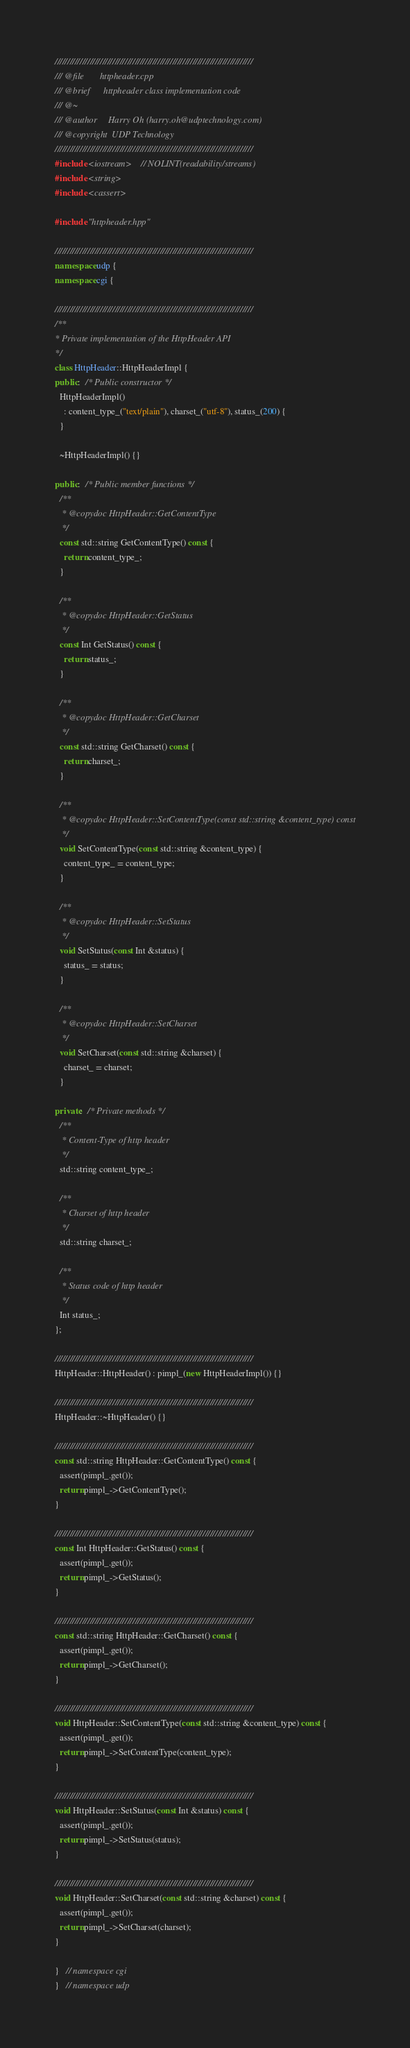Convert code to text. <code><loc_0><loc_0><loc_500><loc_500><_C++_>///////////////////////////////////////////////////////////////////////////////
/// @file       httpheader.cpp
/// @brief      httpheader class implementation code
/// @~
/// @author     Harry Oh (harry.oh@udptechnology.com)
/// @copyright  UDP Technology
///////////////////////////////////////////////////////////////////////////////
#include <iostream>    // NOLINT(readability/streams)
#include <string>
#include <cassert>

#include "httpheader.hpp"

///////////////////////////////////////////////////////////////////////////////
namespace udp {
namespace cgi {

///////////////////////////////////////////////////////////////////////////////
/**
* Private implementation of the HttpHeader API
*/
class HttpHeader::HttpHeaderImpl {
public:  /* Public constructor */
  HttpHeaderImpl()
    : content_type_("text/plain"), charset_("utf-8"), status_(200) {
  }

  ~HttpHeaderImpl() {}

public:  /* Public member functions */
  /**
   * @copydoc HttpHeader::GetContentType
   */
  const std::string GetContentType() const {
    return content_type_;
  }

  /**
   * @copydoc HttpHeader::GetStatus
   */
  const Int GetStatus() const {
    return status_;
  }

  /**
   * @copydoc HttpHeader::GetCharset
   */
  const std::string GetCharset() const {
    return charset_;
  }

  /**
   * @copydoc HttpHeader::SetContentType(const std::string &content_type) const
   */
  void SetContentType(const std::string &content_type) {
    content_type_ = content_type;
  }

  /**
   * @copydoc HttpHeader::SetStatus
   */
  void SetStatus(const Int &status) {
    status_ = status;
  }

  /**
   * @copydoc HttpHeader::SetCharset
   */
  void SetCharset(const std::string &charset) {
    charset_ = charset;
  }

private:  /* Private methods */
  /**
   * Content-Type of http header
   */
  std::string content_type_;

  /**
   * Charset of http header
   */
  std::string charset_;

  /**
   * Status code of http header
   */
  Int status_;
};

///////////////////////////////////////////////////////////////////////////////
HttpHeader::HttpHeader() : pimpl_(new HttpHeaderImpl()) {}

///////////////////////////////////////////////////////////////////////////////
HttpHeader::~HttpHeader() {}

///////////////////////////////////////////////////////////////////////////////
const std::string HttpHeader::GetContentType() const {
  assert(pimpl_.get());
  return pimpl_->GetContentType();
}

///////////////////////////////////////////////////////////////////////////////
const Int HttpHeader::GetStatus() const {
  assert(pimpl_.get());
  return pimpl_->GetStatus();
}

///////////////////////////////////////////////////////////////////////////////
const std::string HttpHeader::GetCharset() const {
  assert(pimpl_.get());
  return pimpl_->GetCharset();
}

///////////////////////////////////////////////////////////////////////////////
void HttpHeader::SetContentType(const std::string &content_type) const {
  assert(pimpl_.get());
  return pimpl_->SetContentType(content_type);
}

///////////////////////////////////////////////////////////////////////////////
void HttpHeader::SetStatus(const Int &status) const {
  assert(pimpl_.get());
  return pimpl_->SetStatus(status);
}

///////////////////////////////////////////////////////////////////////////////
void HttpHeader::SetCharset(const std::string &charset) const {
  assert(pimpl_.get());
  return pimpl_->SetCharset(charset);
}

}   // namespace cgi
}   // namespace udp
</code> 